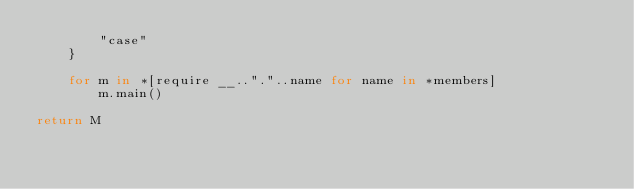Convert code to text. <code><loc_0><loc_0><loc_500><loc_500><_MoonScript_>        "case"
    }

    for m in *[require __.."."..name for name in *members]
        m.main()

return M</code> 